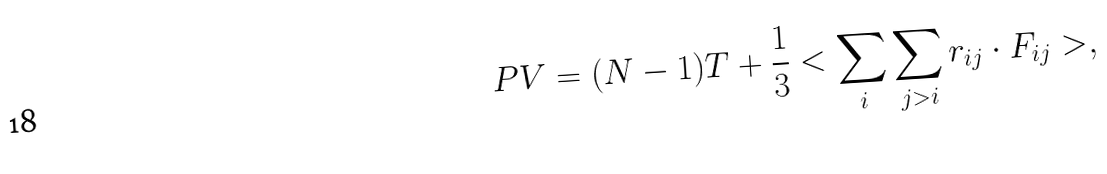Convert formula to latex. <formula><loc_0><loc_0><loc_500><loc_500>P V = ( N - 1 ) T + \frac { 1 } { 3 } < \sum _ { i } \sum _ { j > i } { r } _ { i j } \cdot { F } _ { i j } > ,</formula> 